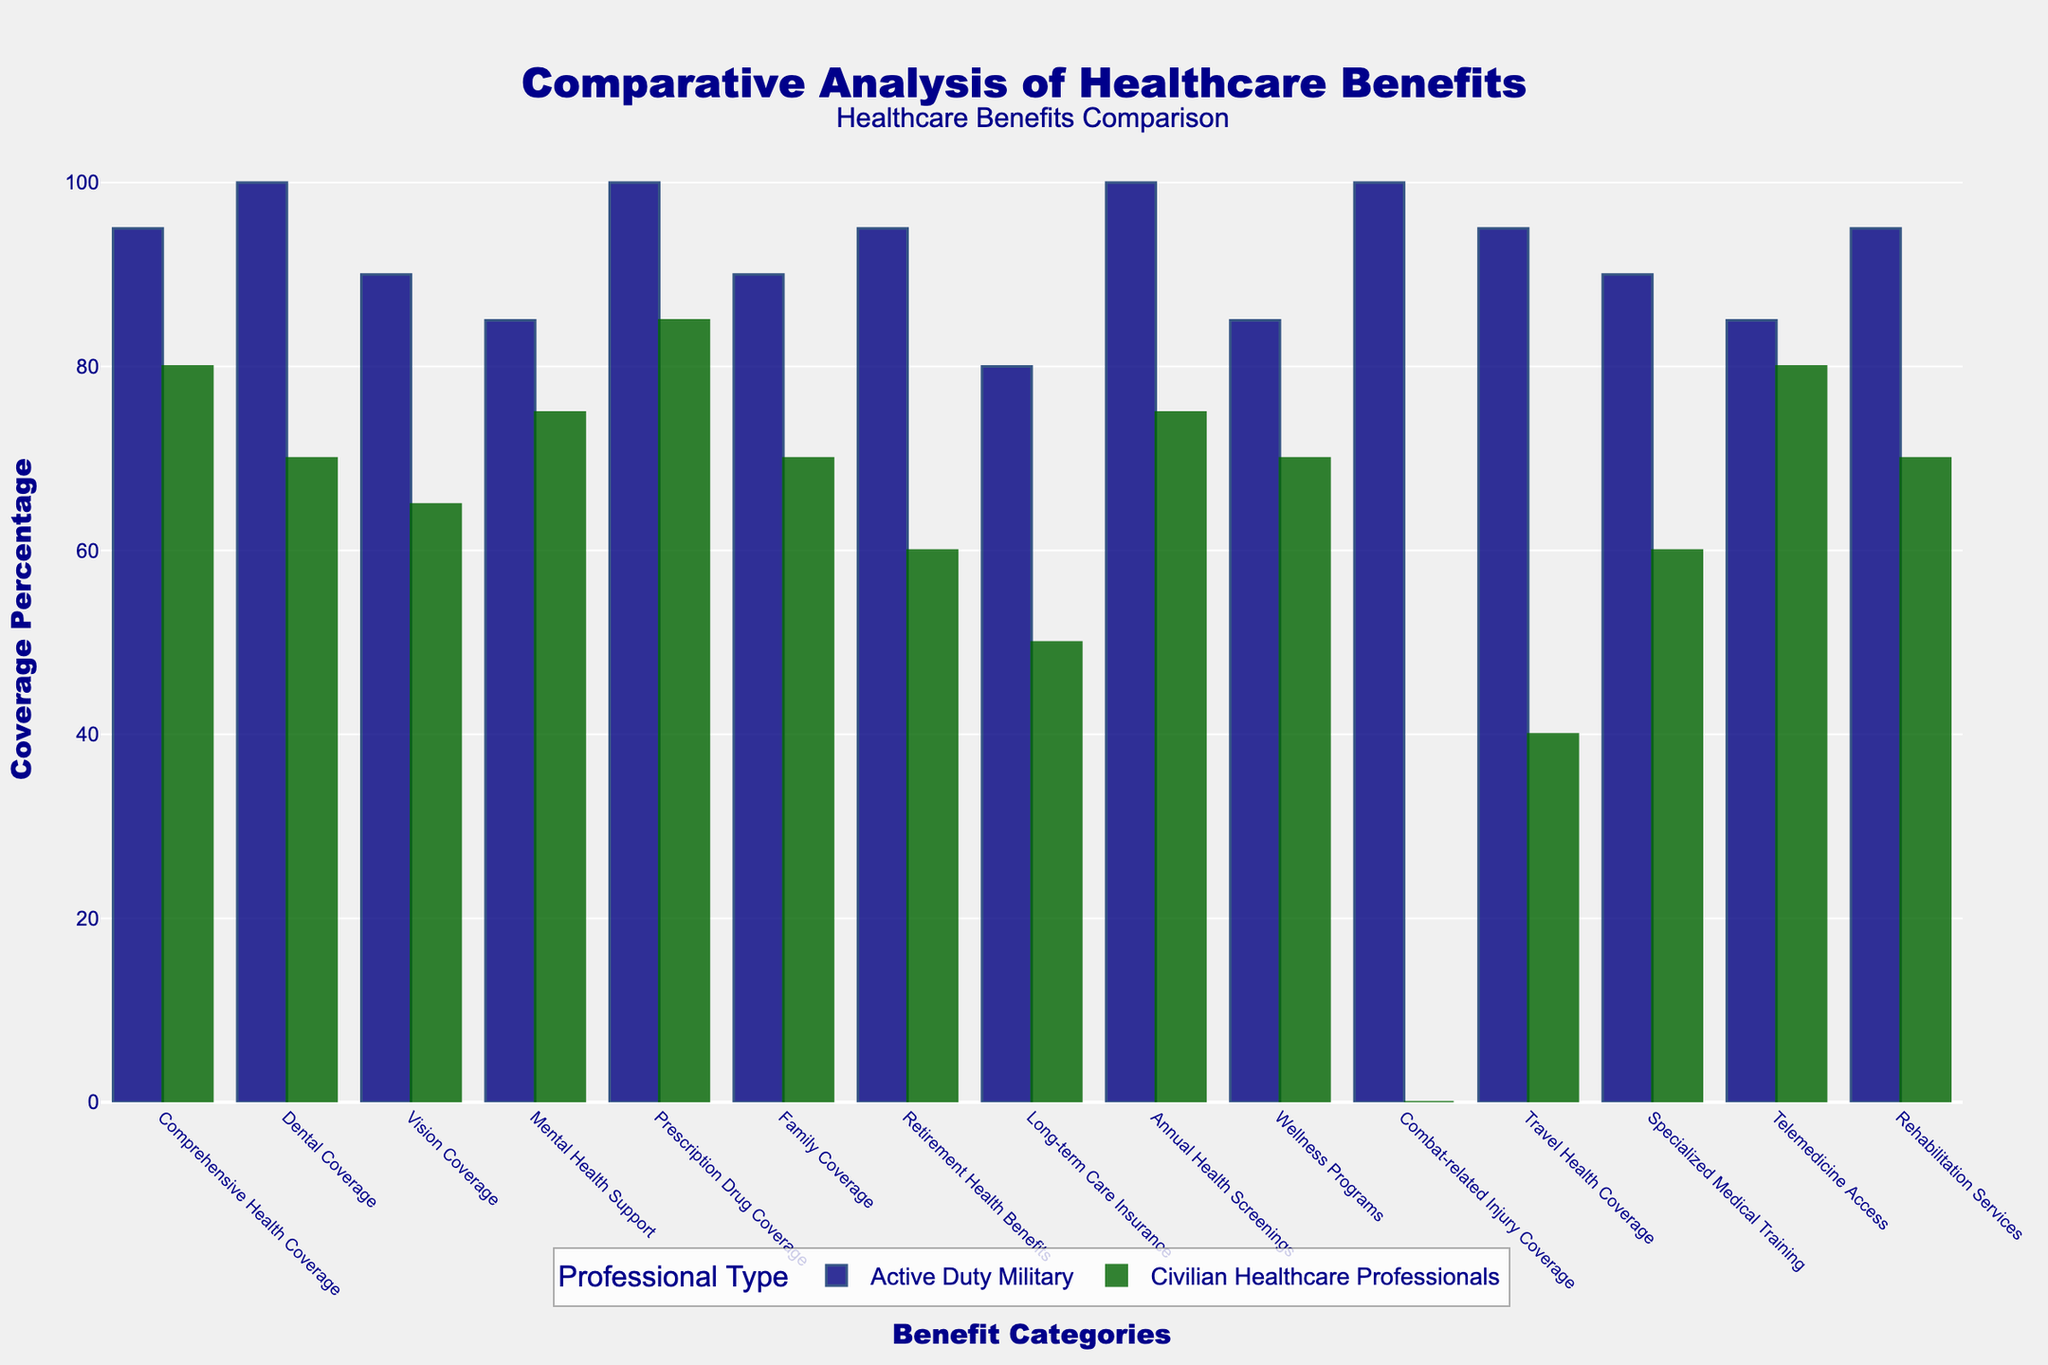What's the coverage percentage for Comprehensive Health Coverage for both Active Duty Military and Civilian Healthcare Professionals? For Active Duty Military, the bar for Comprehensive Health Coverage reaches 95%. For Civilian Healthcare Professionals, the bar reaches 80%.
Answer: Active Duty Military: 95%, Civilian Healthcare Professionals: 80% Which benefit category shows the largest difference in coverage percentage between Active Duty Military and Civilian Healthcare Professionals? Combat-related Injury Coverage shows the largest difference, with Active Duty Military at 100% and Civilians at 0%, giving a difference of 100%.
Answer: Combat-related Injury Coverage What's the average coverage percentage for Vision Coverage and Mental Health Support for Active Duty Military? For Active Duty Military, Vision Coverage is 90% and Mental Health Support is 85%. The average is (90 + 85) / 2 = 87.5%.
Answer: 87.5% Which benefit category has equal coverage percentages for both Active Duty Military and Civilian Healthcare Professionals? The bars for Telemedicine Access are of equal height for both groups, both showing a coverage percentage of 85%.
Answer: Telemedicine Access By how much does the coverage percentage of Dental Coverage differ between Active Duty Military and Civilian Healthcare Professionals? The coverage percentage for Dental Coverage in Active Duty Military is 100% and 70% for Civilian Healthcare Professionals. The difference is 100 - 70 = 30%.
Answer: 30% In which benefit category do Active Duty Military have the same coverage percentage of 100%, and Civilian Healthcare Professionals have zero coverage? The Combat-related Injury Coverage bar for Active Duty Military is at 100% while Civilian Healthcare Professionals has zero coverage.
Answer: Combat-related Injury Coverage How many benefit categories have a coverage percentage of 100% for Active Duty Military? By counting the bars, we see that Comprehensive Health Coverage, Dental Coverage, Prescription Drug Coverage, Annual Health Screenings, and Combat-related Injury Coverage all have a coverage percentage of 100%. This totals to 5 categories.
Answer: 5 Compare the coverage percentages for Family Coverage in both groups and establish which group has better coverage. Family Coverage for Active Duty Military is 90%, whereas for Civilian Healthcare Professionals it is 70%. This indicates better coverage for Active Duty Military.
Answer: Active Duty Military What's the sum of the coverage percentages for Long-term Care Insurance and Travel Health Coverage for Civilian Healthcare Professionals? Long-term Care Insurance has a coverage percentage of 50%, while Travel Health Coverage has 40%. Their sum is 50 + 40 = 90%.
Answer: 90% 